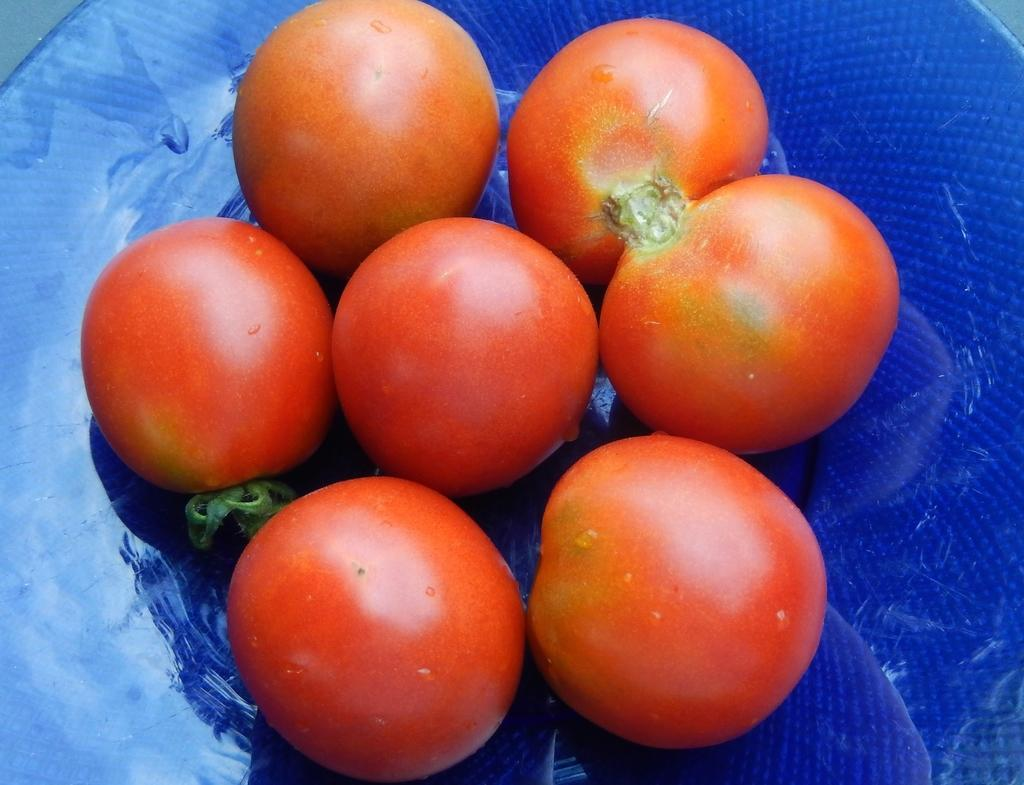What type of food is placed on the plate in the image? There are tomatoes placed on a plate in the image. What is the color of the plate? The plate is in blue color. Where can the shop receipt for the tomatoes be found in the image? There is no shop receipt present in the image. 